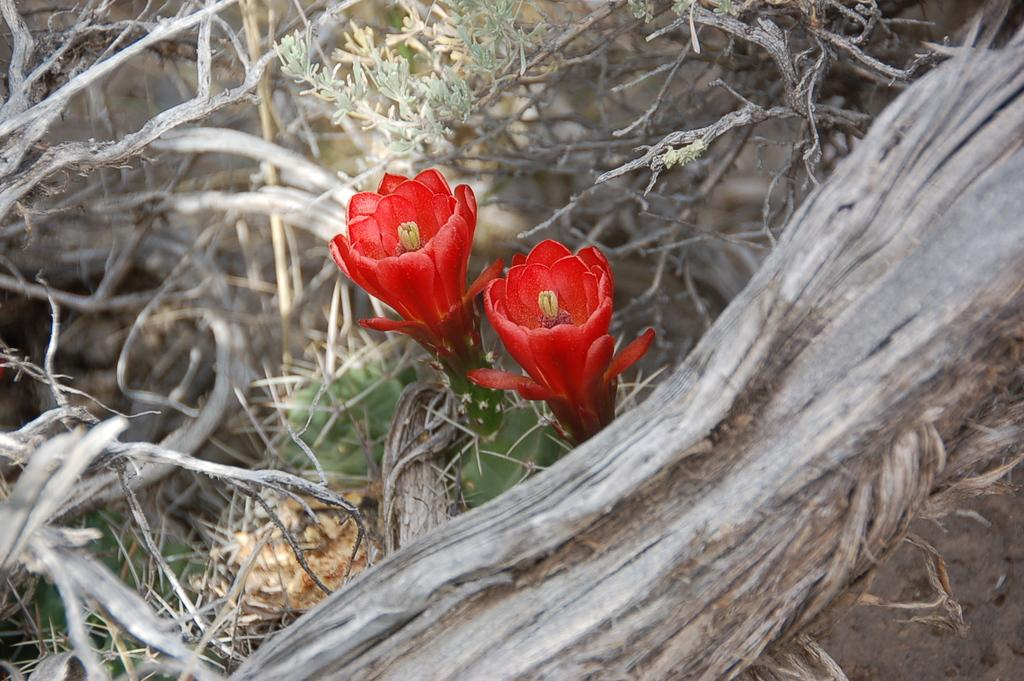How many flowers can be seen in the image? There are two flowers in the image. What color are the flowers? The flowers are red in color. What other elements are present in the image besides the flowers? There are twigs and leaves in the image. Can you describe the background of the image? The backdrop of the image is blurred. What type of pickle is hanging from the twigs in the image? There is no pickle present in the image; it features two red flowers, twigs, and leaves. Is there a beast visible in the image? There is no beast present in the image. 